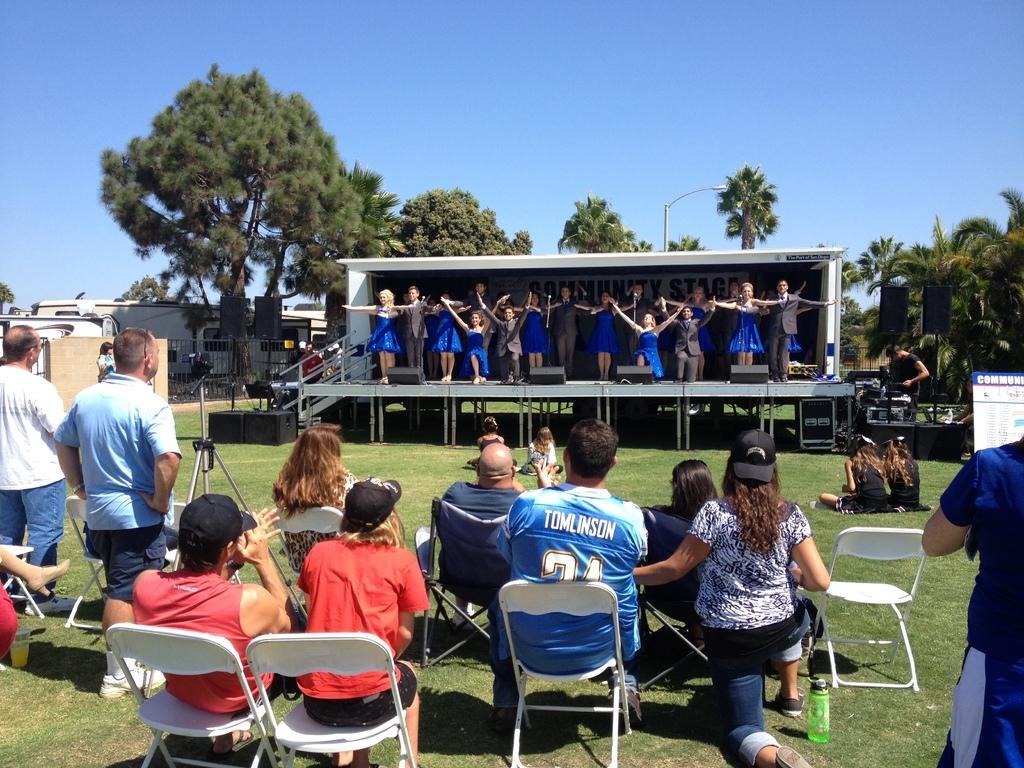Can you describe this image briefly? group of people they are dancing on stage and some people they are sitting on the stage and behind the person who are dancing there are so many trees and the persons who are standing and watching. 